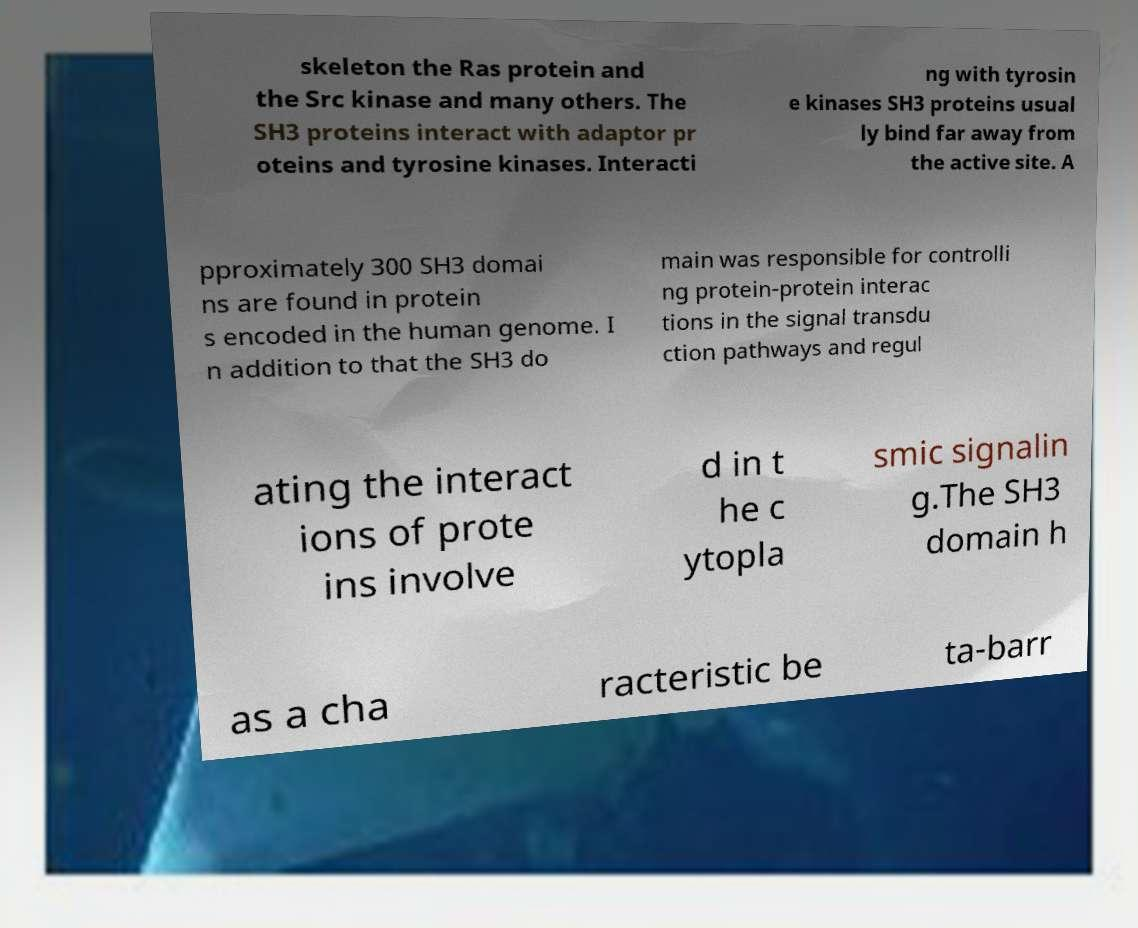Please identify and transcribe the text found in this image. skeleton the Ras protein and the Src kinase and many others. The SH3 proteins interact with adaptor pr oteins and tyrosine kinases. Interacti ng with tyrosin e kinases SH3 proteins usual ly bind far away from the active site. A pproximately 300 SH3 domai ns are found in protein s encoded in the human genome. I n addition to that the SH3 do main was responsible for controlli ng protein-protein interac tions in the signal transdu ction pathways and regul ating the interact ions of prote ins involve d in t he c ytopla smic signalin g.The SH3 domain h as a cha racteristic be ta-barr 